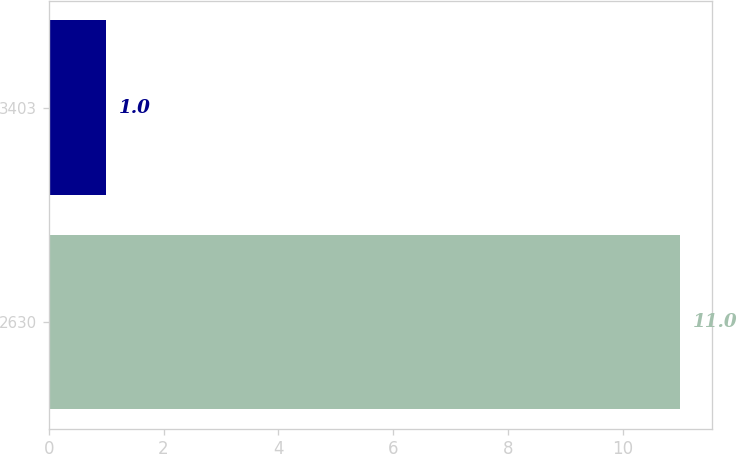<chart> <loc_0><loc_0><loc_500><loc_500><bar_chart><fcel>2630<fcel>3403<nl><fcel>11<fcel>1<nl></chart> 